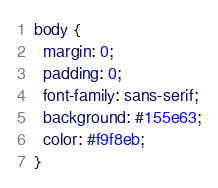Convert code to text. <code><loc_0><loc_0><loc_500><loc_500><_CSS_>body {
  margin: 0;
  padding: 0;
  font-family: sans-serif;
  background: #155e63;
  color: #f9f8eb;
}
</code> 